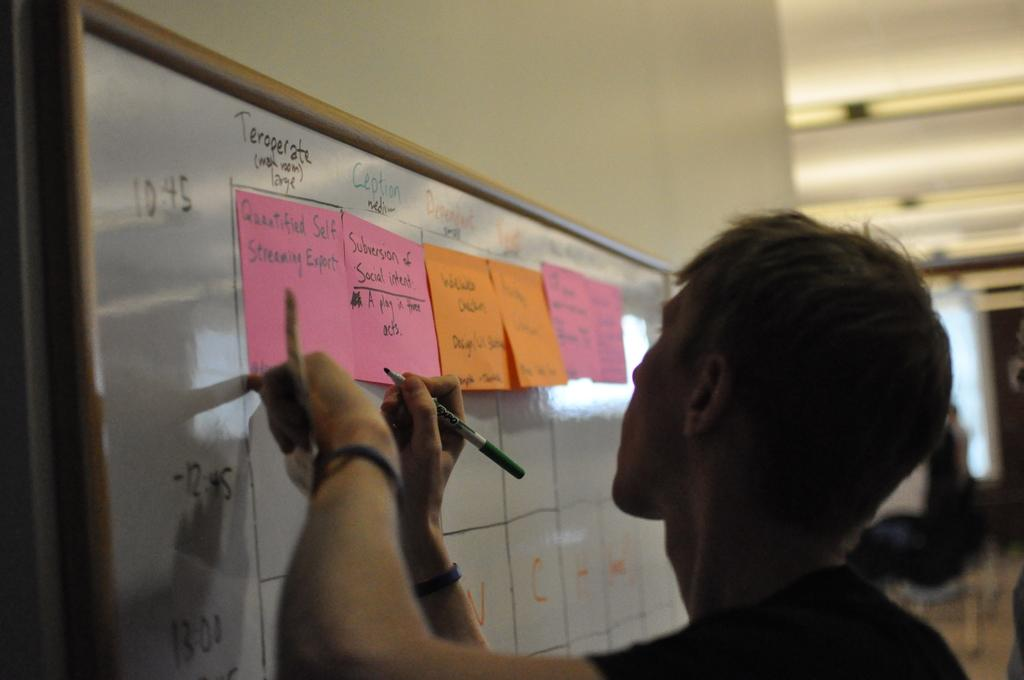<image>
Present a compact description of the photo's key features. a person writes on a white board with post its reading Quatified Self Streaming Expert 